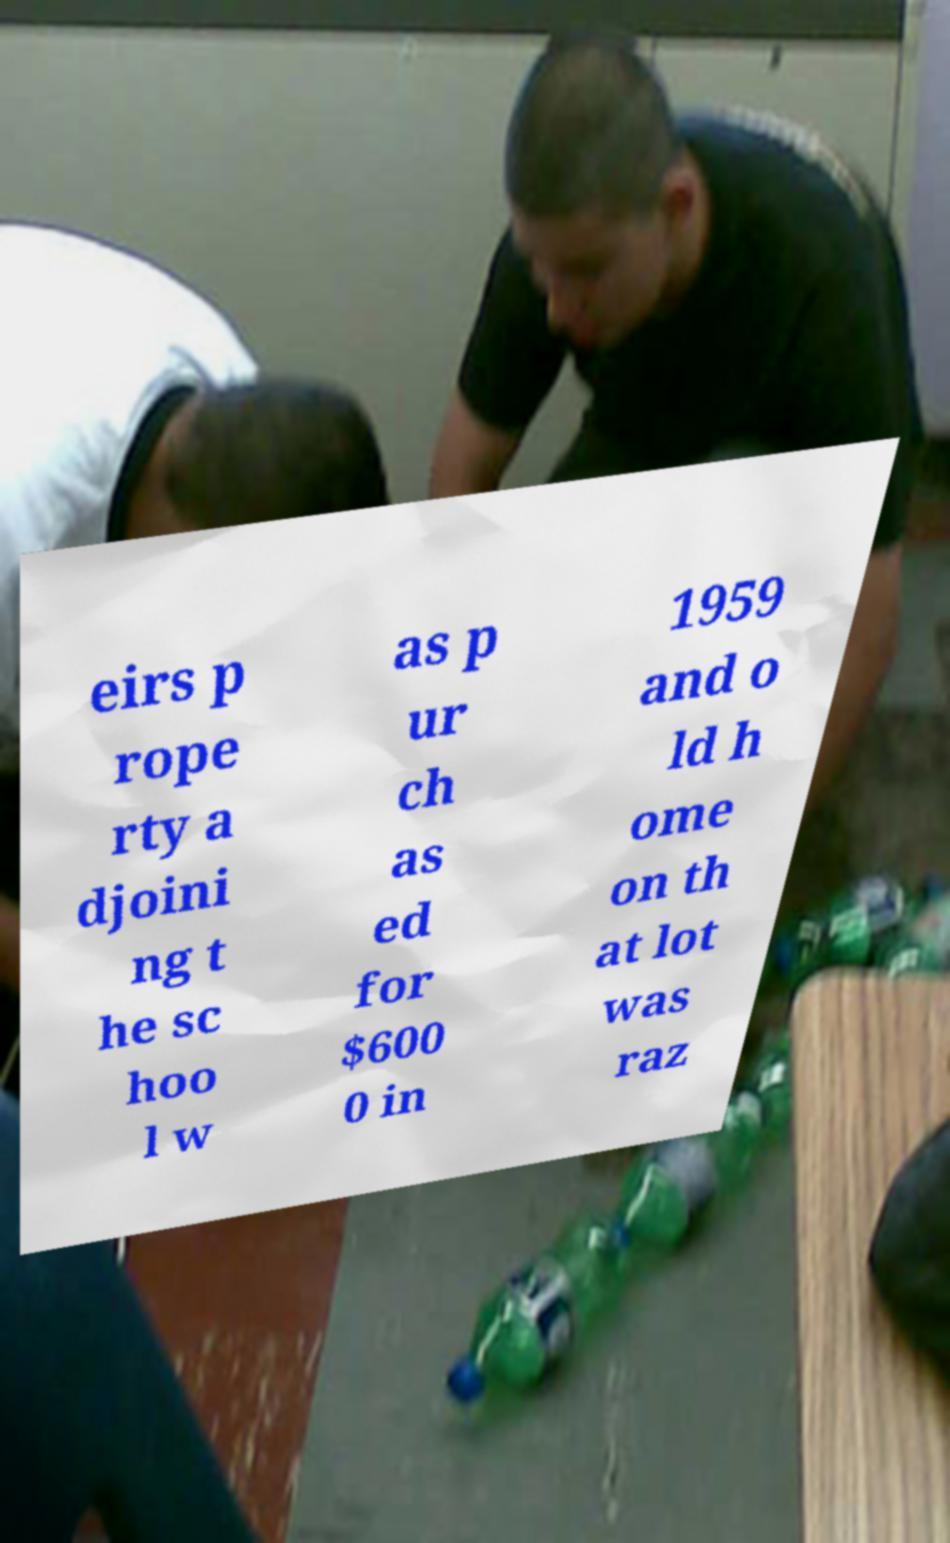Could you assist in decoding the text presented in this image and type it out clearly? eirs p rope rty a djoini ng t he sc hoo l w as p ur ch as ed for $600 0 in 1959 and o ld h ome on th at lot was raz 